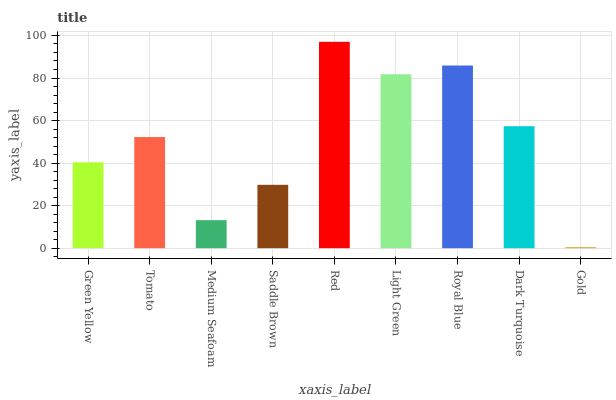Is Gold the minimum?
Answer yes or no. Yes. Is Red the maximum?
Answer yes or no. Yes. Is Tomato the minimum?
Answer yes or no. No. Is Tomato the maximum?
Answer yes or no. No. Is Tomato greater than Green Yellow?
Answer yes or no. Yes. Is Green Yellow less than Tomato?
Answer yes or no. Yes. Is Green Yellow greater than Tomato?
Answer yes or no. No. Is Tomato less than Green Yellow?
Answer yes or no. No. Is Tomato the high median?
Answer yes or no. Yes. Is Tomato the low median?
Answer yes or no. Yes. Is Medium Seafoam the high median?
Answer yes or no. No. Is Dark Turquoise the low median?
Answer yes or no. No. 